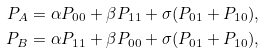<formula> <loc_0><loc_0><loc_500><loc_500>P _ { A } & = \alpha P _ { 0 0 } + \beta P _ { 1 1 } + \sigma ( P _ { 0 1 } + P _ { 1 0 } ) , \\ P _ { B } & = \alpha P _ { 1 1 } + \beta P _ { 0 0 } + \sigma ( P _ { 0 1 } + P _ { 1 0 } ) ,</formula> 